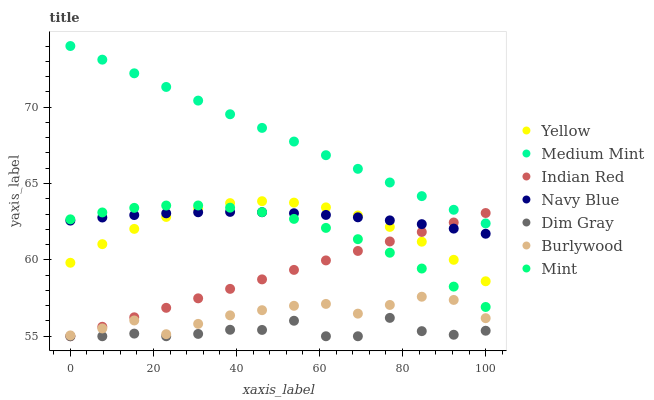Does Dim Gray have the minimum area under the curve?
Answer yes or no. Yes. Does Medium Mint have the maximum area under the curve?
Answer yes or no. Yes. Does Burlywood have the minimum area under the curve?
Answer yes or no. No. Does Burlywood have the maximum area under the curve?
Answer yes or no. No. Is Indian Red the smoothest?
Answer yes or no. Yes. Is Dim Gray the roughest?
Answer yes or no. Yes. Is Burlywood the smoothest?
Answer yes or no. No. Is Burlywood the roughest?
Answer yes or no. No. Does Dim Gray have the lowest value?
Answer yes or no. Yes. Does Burlywood have the lowest value?
Answer yes or no. No. Does Medium Mint have the highest value?
Answer yes or no. Yes. Does Burlywood have the highest value?
Answer yes or no. No. Is Mint less than Medium Mint?
Answer yes or no. Yes. Is Yellow greater than Dim Gray?
Answer yes or no. Yes. Does Yellow intersect Navy Blue?
Answer yes or no. Yes. Is Yellow less than Navy Blue?
Answer yes or no. No. Is Yellow greater than Navy Blue?
Answer yes or no. No. Does Mint intersect Medium Mint?
Answer yes or no. No. 